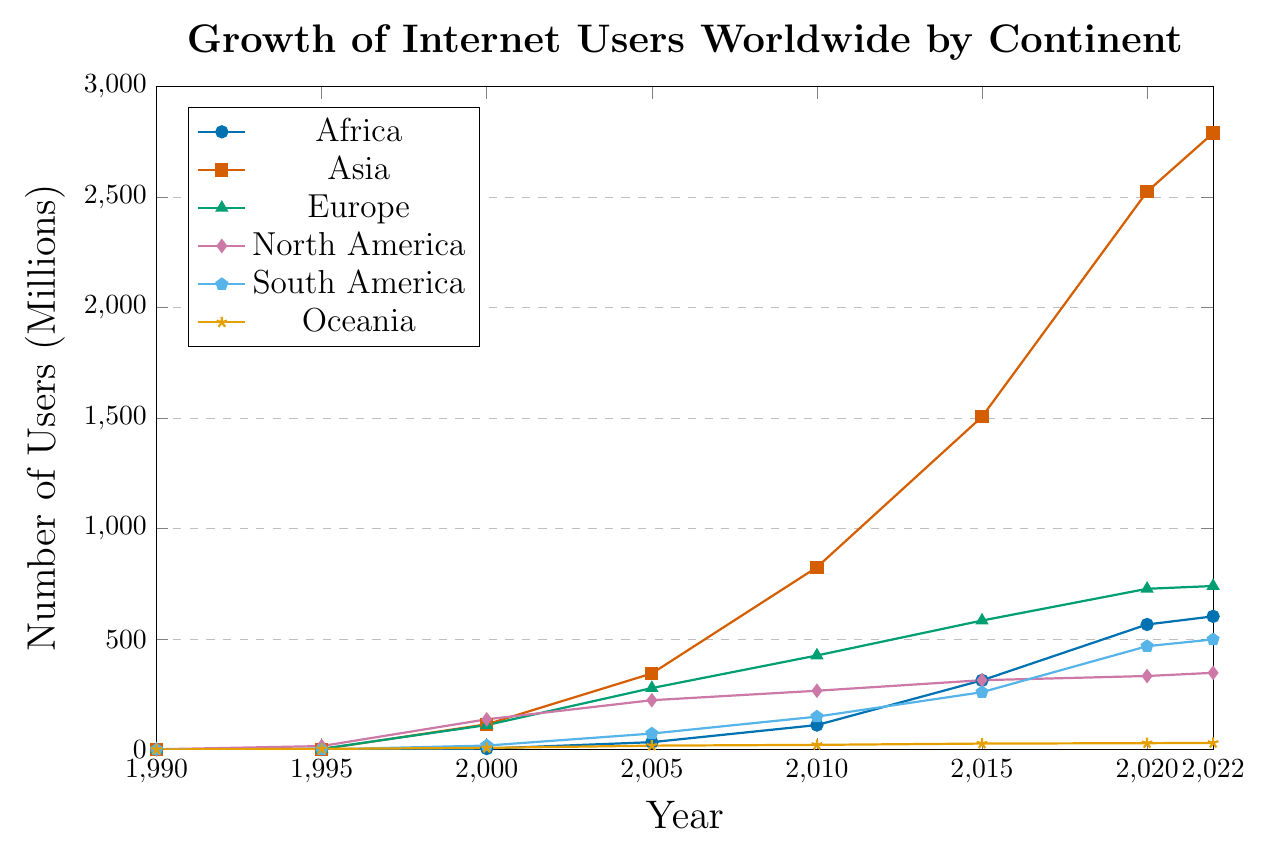What's the trend in the number of internet users in Asia from 1990 to 2022? To identify the trend, observe the plotted line for Asia (orange with square marks) from 1990 to 2022. The number of internet users in Asia has grown rapidly over this period, starting from 0.1 million in 1990 to 2790.2 million in 2022.
Answer: Rapid increase Which continent had the highest number of internet users in 2022? Check the values for 2022 on the y-axis for all continents. Asia (orange with square marks) reaches the highest value at 2790.2 million.
Answer: Asia In which year did Europe surpass 400 million internet users? Follow the plotted line for Europe (green with triangle marks) and identify the year when the user count first exceeds 400 million. This occurs between 2005 and 2010, so the exact year can be inferred as 2010.
Answer: 2010 In 2015, which continent had more internet users, Africa or South America? By how much? Compare the values for Africa and South America in 2015. Africa has 313.3 million users, and South America has 259.7 million users. The difference is 313.3 - 259.7 = 53.6 million users.
Answer: Africa by 53.6 million How did the number of internet users in Oceania change from 2010 to 2022? Evaluate the plotted line for Oceania (brown with star marks) between 2010 and 2022. The values are 21.3 million in 2010 and 30.1 million in 2022, indicating an increase.
Answer: Increased Which continent experienced the sharpest increase in internet users between 1995 and 2000? Compare the slopes of the lines between 1995 and 2000. Asia's (orange with square marks) line shows the steepest increase, starting at 1.5 million and jumping to 114.3 million.
Answer: Asia What is the overall growth rate of internet users in North America from 1995 to 2022? Calculate the difference between the values in 1995 and 2022 for North America (red with diamond marks). 347.4 million in 2022 minus 15.8 million in 1995 equals 331.6 million. Then, divide by the initial value (15.8 million) and convert to percentage: (331.6 / 15.8) * 100 ≈ 2098.73%.
Answer: 2098.73% What is the combined number of internet users in Europe and North America in 2022? Add the values for Europe and North America in 2022. Europe has 740.2 million and North America has 347.4 million users. 740.2 + 347.4 = 1087.6 million users.
Answer: 1087.6 million Which continent had the slowest growth in internet users from 2000 to 2005? Evaluate the slopes of the lines between 2000 and 2005. Oceania's (brown with star marks) line shows the smallest increase, moving from 7.6 million to 17.7 million.
Answer: Oceania In the year 2000, which two continents had nearly the same number of internet users and what were their values? Compare the values for all continents in the year 2000. Europe (110.8 million) and Asia (114.3 million) have closely matching numbers.
Answer: Europe (110.8 million) and Asia (114.3 million) 